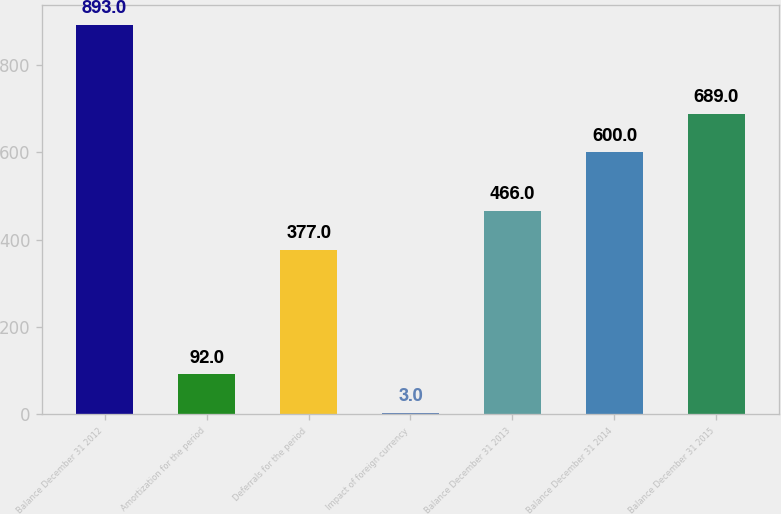Convert chart. <chart><loc_0><loc_0><loc_500><loc_500><bar_chart><fcel>Balance December 31 2012<fcel>Amortization for the period<fcel>Deferrals for the period<fcel>Impact of foreign currency<fcel>Balance December 31 2013<fcel>Balance December 31 2014<fcel>Balance December 31 2015<nl><fcel>893<fcel>92<fcel>377<fcel>3<fcel>466<fcel>600<fcel>689<nl></chart> 